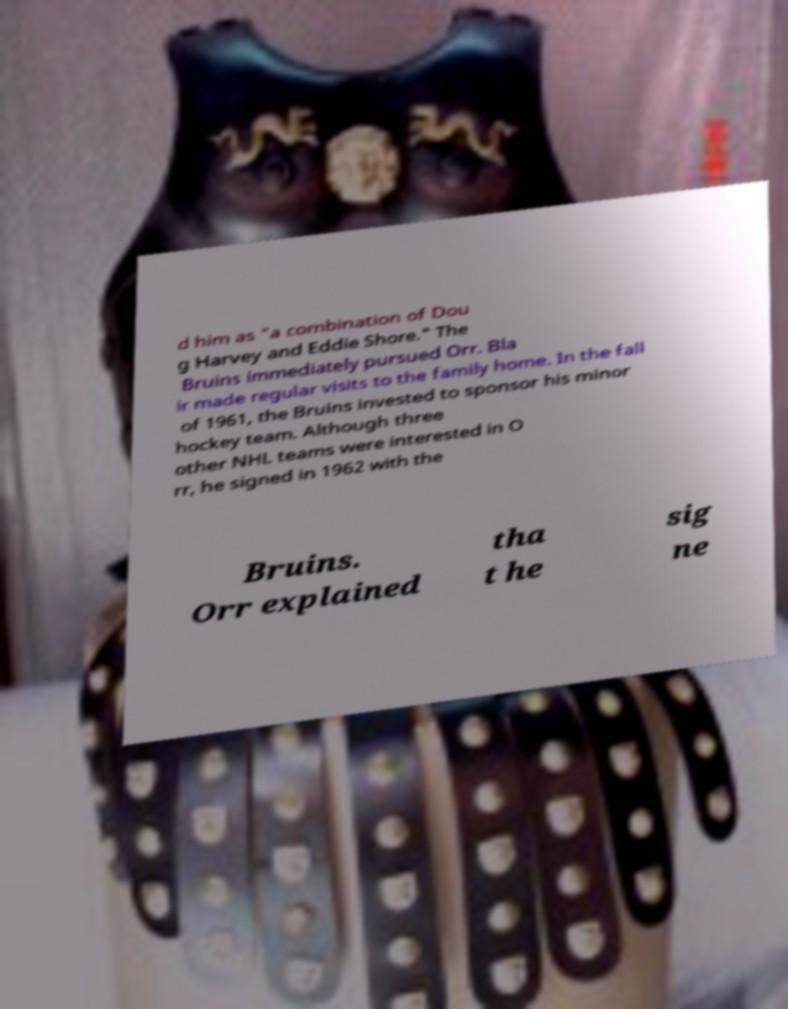I need the written content from this picture converted into text. Can you do that? d him as "a combination of Dou g Harvey and Eddie Shore." The Bruins immediately pursued Orr. Bla ir made regular visits to the family home. In the fall of 1961, the Bruins invested to sponsor his minor hockey team. Although three other NHL teams were interested in O rr, he signed in 1962 with the Bruins. Orr explained tha t he sig ne 